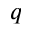Convert formula to latex. <formula><loc_0><loc_0><loc_500><loc_500>q</formula> 